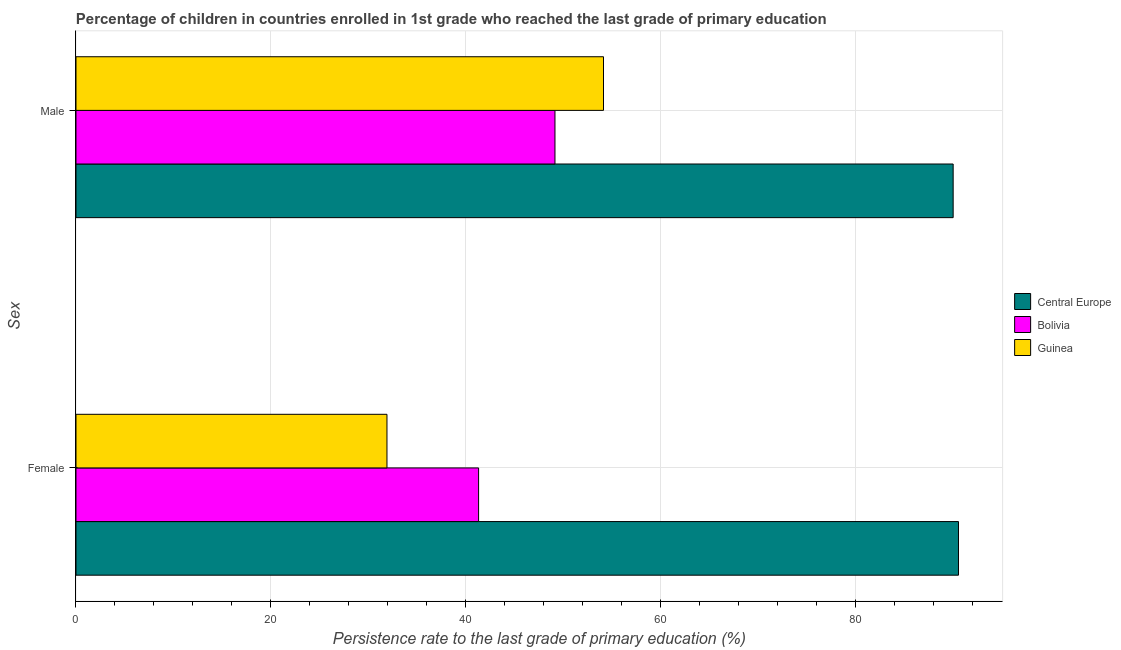How many bars are there on the 1st tick from the bottom?
Ensure brevity in your answer.  3. What is the persistence rate of female students in Guinea?
Your answer should be compact. 31.9. Across all countries, what is the maximum persistence rate of female students?
Offer a terse response. 90.52. Across all countries, what is the minimum persistence rate of male students?
Provide a short and direct response. 49.13. In which country was the persistence rate of male students maximum?
Provide a short and direct response. Central Europe. In which country was the persistence rate of female students minimum?
Provide a short and direct response. Guinea. What is the total persistence rate of male students in the graph?
Provide a succinct answer. 193.21. What is the difference between the persistence rate of male students in Guinea and that in Bolivia?
Your answer should be compact. 4.98. What is the difference between the persistence rate of female students in Bolivia and the persistence rate of male students in Central Europe?
Give a very brief answer. -48.68. What is the average persistence rate of female students per country?
Provide a succinct answer. 54.57. What is the difference between the persistence rate of female students and persistence rate of male students in Guinea?
Provide a short and direct response. -22.21. What is the ratio of the persistence rate of male students in Central Europe to that in Guinea?
Your answer should be very brief. 1.66. In how many countries, is the persistence rate of male students greater than the average persistence rate of male students taken over all countries?
Your response must be concise. 1. What does the 1st bar from the top in Female represents?
Ensure brevity in your answer.  Guinea. What does the 1st bar from the bottom in Female represents?
Your answer should be compact. Central Europe. How many bars are there?
Offer a terse response. 6. What is the difference between two consecutive major ticks on the X-axis?
Offer a very short reply. 20. Are the values on the major ticks of X-axis written in scientific E-notation?
Offer a very short reply. No. Does the graph contain any zero values?
Make the answer very short. No. How many legend labels are there?
Keep it short and to the point. 3. How are the legend labels stacked?
Provide a succinct answer. Vertical. What is the title of the graph?
Provide a short and direct response. Percentage of children in countries enrolled in 1st grade who reached the last grade of primary education. What is the label or title of the X-axis?
Ensure brevity in your answer.  Persistence rate to the last grade of primary education (%). What is the label or title of the Y-axis?
Your answer should be compact. Sex. What is the Persistence rate to the last grade of primary education (%) in Central Europe in Female?
Make the answer very short. 90.52. What is the Persistence rate to the last grade of primary education (%) of Bolivia in Female?
Your answer should be very brief. 41.29. What is the Persistence rate to the last grade of primary education (%) in Guinea in Female?
Keep it short and to the point. 31.9. What is the Persistence rate to the last grade of primary education (%) in Central Europe in Male?
Make the answer very short. 89.97. What is the Persistence rate to the last grade of primary education (%) in Bolivia in Male?
Your answer should be compact. 49.13. What is the Persistence rate to the last grade of primary education (%) of Guinea in Male?
Ensure brevity in your answer.  54.11. Across all Sex, what is the maximum Persistence rate to the last grade of primary education (%) in Central Europe?
Offer a terse response. 90.52. Across all Sex, what is the maximum Persistence rate to the last grade of primary education (%) in Bolivia?
Provide a succinct answer. 49.13. Across all Sex, what is the maximum Persistence rate to the last grade of primary education (%) in Guinea?
Your answer should be very brief. 54.11. Across all Sex, what is the minimum Persistence rate to the last grade of primary education (%) of Central Europe?
Give a very brief answer. 89.97. Across all Sex, what is the minimum Persistence rate to the last grade of primary education (%) in Bolivia?
Offer a very short reply. 41.29. Across all Sex, what is the minimum Persistence rate to the last grade of primary education (%) of Guinea?
Make the answer very short. 31.9. What is the total Persistence rate to the last grade of primary education (%) in Central Europe in the graph?
Your answer should be very brief. 180.49. What is the total Persistence rate to the last grade of primary education (%) in Bolivia in the graph?
Provide a short and direct response. 90.42. What is the total Persistence rate to the last grade of primary education (%) in Guinea in the graph?
Give a very brief answer. 86. What is the difference between the Persistence rate to the last grade of primary education (%) of Central Europe in Female and that in Male?
Offer a very short reply. 0.55. What is the difference between the Persistence rate to the last grade of primary education (%) in Bolivia in Female and that in Male?
Ensure brevity in your answer.  -7.83. What is the difference between the Persistence rate to the last grade of primary education (%) in Guinea in Female and that in Male?
Give a very brief answer. -22.21. What is the difference between the Persistence rate to the last grade of primary education (%) in Central Europe in Female and the Persistence rate to the last grade of primary education (%) in Bolivia in Male?
Your answer should be compact. 41.39. What is the difference between the Persistence rate to the last grade of primary education (%) of Central Europe in Female and the Persistence rate to the last grade of primary education (%) of Guinea in Male?
Provide a short and direct response. 36.41. What is the difference between the Persistence rate to the last grade of primary education (%) in Bolivia in Female and the Persistence rate to the last grade of primary education (%) in Guinea in Male?
Offer a terse response. -12.81. What is the average Persistence rate to the last grade of primary education (%) of Central Europe per Sex?
Make the answer very short. 90.24. What is the average Persistence rate to the last grade of primary education (%) in Bolivia per Sex?
Make the answer very short. 45.21. What is the average Persistence rate to the last grade of primary education (%) of Guinea per Sex?
Provide a succinct answer. 43. What is the difference between the Persistence rate to the last grade of primary education (%) of Central Europe and Persistence rate to the last grade of primary education (%) of Bolivia in Female?
Your answer should be very brief. 49.22. What is the difference between the Persistence rate to the last grade of primary education (%) in Central Europe and Persistence rate to the last grade of primary education (%) in Guinea in Female?
Your response must be concise. 58.62. What is the difference between the Persistence rate to the last grade of primary education (%) of Bolivia and Persistence rate to the last grade of primary education (%) of Guinea in Female?
Your answer should be compact. 9.4. What is the difference between the Persistence rate to the last grade of primary education (%) of Central Europe and Persistence rate to the last grade of primary education (%) of Bolivia in Male?
Make the answer very short. 40.84. What is the difference between the Persistence rate to the last grade of primary education (%) of Central Europe and Persistence rate to the last grade of primary education (%) of Guinea in Male?
Offer a terse response. 35.86. What is the difference between the Persistence rate to the last grade of primary education (%) of Bolivia and Persistence rate to the last grade of primary education (%) of Guinea in Male?
Your answer should be very brief. -4.98. What is the ratio of the Persistence rate to the last grade of primary education (%) in Central Europe in Female to that in Male?
Offer a very short reply. 1.01. What is the ratio of the Persistence rate to the last grade of primary education (%) in Bolivia in Female to that in Male?
Your answer should be very brief. 0.84. What is the ratio of the Persistence rate to the last grade of primary education (%) in Guinea in Female to that in Male?
Ensure brevity in your answer.  0.59. What is the difference between the highest and the second highest Persistence rate to the last grade of primary education (%) of Central Europe?
Keep it short and to the point. 0.55. What is the difference between the highest and the second highest Persistence rate to the last grade of primary education (%) of Bolivia?
Your answer should be very brief. 7.83. What is the difference between the highest and the second highest Persistence rate to the last grade of primary education (%) in Guinea?
Offer a terse response. 22.21. What is the difference between the highest and the lowest Persistence rate to the last grade of primary education (%) in Central Europe?
Provide a succinct answer. 0.55. What is the difference between the highest and the lowest Persistence rate to the last grade of primary education (%) in Bolivia?
Your answer should be compact. 7.83. What is the difference between the highest and the lowest Persistence rate to the last grade of primary education (%) of Guinea?
Keep it short and to the point. 22.21. 